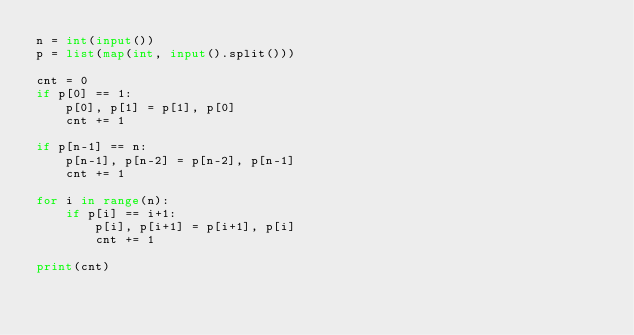Convert code to text. <code><loc_0><loc_0><loc_500><loc_500><_Python_>n = int(input())
p = list(map(int, input().split()))

cnt = 0
if p[0] == 1:
    p[0], p[1] = p[1], p[0]
    cnt += 1

if p[n-1] == n:
    p[n-1], p[n-2] = p[n-2], p[n-1]
    cnt += 1

for i in range(n):
    if p[i] == i+1:
        p[i], p[i+1] = p[i+1], p[i]
        cnt += 1

print(cnt)</code> 